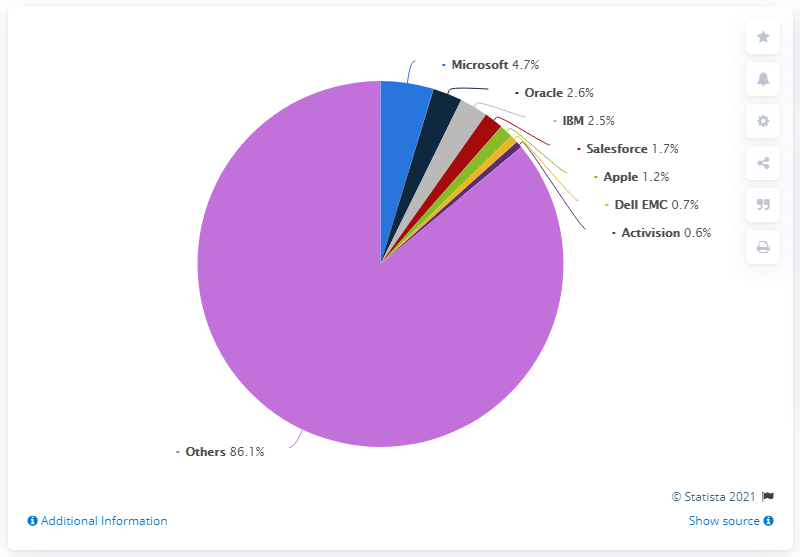Point out several critical features in this image. The pie chart shows the dominance of light purple color segment. Microsoft accounted for approximately 4.7% of the software industry in the year ending June 2019. The quotient when "Others" is divided by Microsoft's market share is 18.31. 